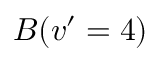Convert formula to latex. <formula><loc_0><loc_0><loc_500><loc_500>B ( v ^ { \prime } = 4 )</formula> 